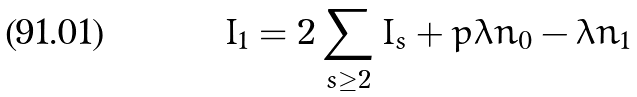<formula> <loc_0><loc_0><loc_500><loc_500>I _ { 1 } = 2 \sum _ { s \geq 2 } I _ { s } + p \lambda n _ { 0 } - \lambda n _ { 1 }</formula> 